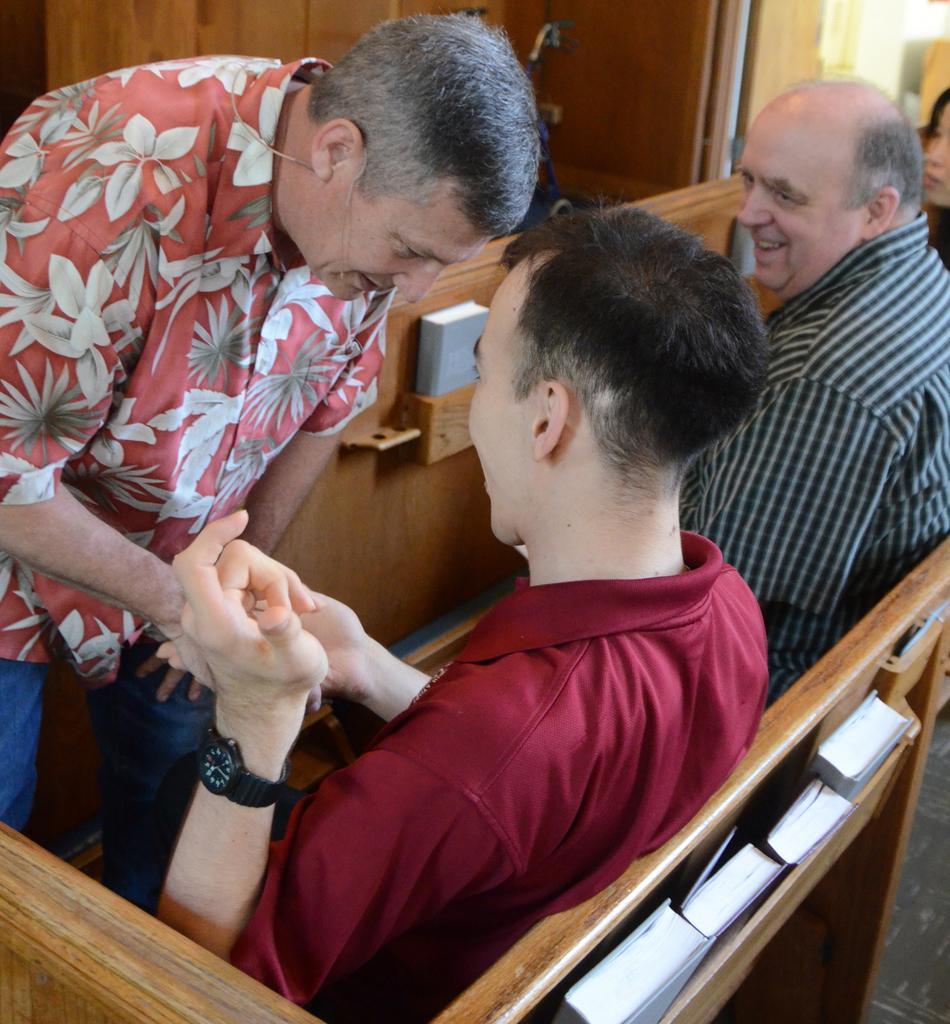How would you summarize this image in a sentence or two? On the left side there is a person standing. Near to him two persons are sitting on benches. On the side of the bench there is a rack. Inside that there are books. 